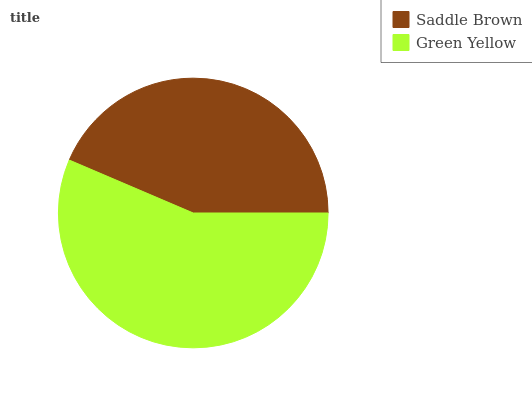Is Saddle Brown the minimum?
Answer yes or no. Yes. Is Green Yellow the maximum?
Answer yes or no. Yes. Is Green Yellow the minimum?
Answer yes or no. No. Is Green Yellow greater than Saddle Brown?
Answer yes or no. Yes. Is Saddle Brown less than Green Yellow?
Answer yes or no. Yes. Is Saddle Brown greater than Green Yellow?
Answer yes or no. No. Is Green Yellow less than Saddle Brown?
Answer yes or no. No. Is Green Yellow the high median?
Answer yes or no. Yes. Is Saddle Brown the low median?
Answer yes or no. Yes. Is Saddle Brown the high median?
Answer yes or no. No. Is Green Yellow the low median?
Answer yes or no. No. 